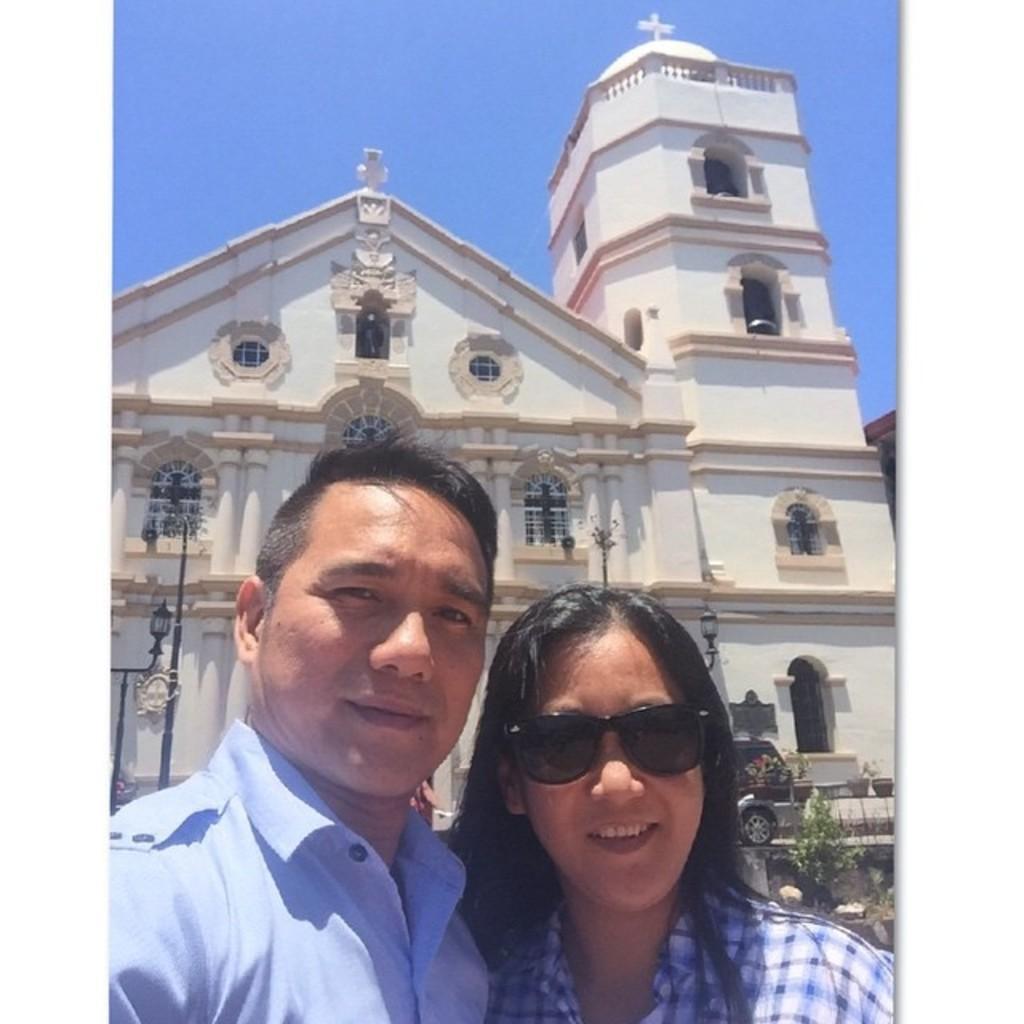Can you describe this image briefly? In the image I can see a lady and a guy who are standing in front of the building and also I can see a cat, trees and poles. 